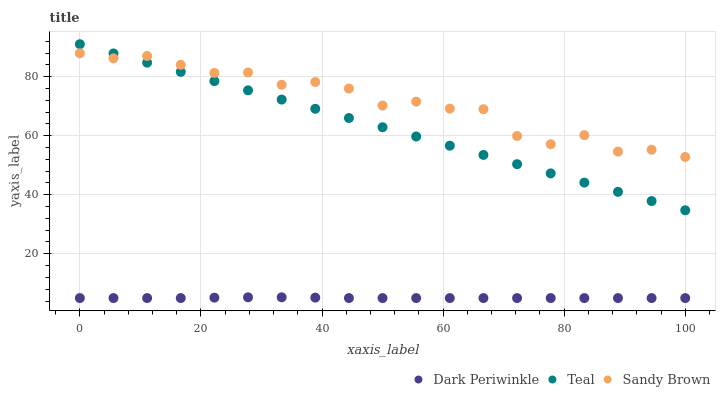Does Dark Periwinkle have the minimum area under the curve?
Answer yes or no. Yes. Does Sandy Brown have the maximum area under the curve?
Answer yes or no. Yes. Does Teal have the minimum area under the curve?
Answer yes or no. No. Does Teal have the maximum area under the curve?
Answer yes or no. No. Is Teal the smoothest?
Answer yes or no. Yes. Is Sandy Brown the roughest?
Answer yes or no. Yes. Is Dark Periwinkle the smoothest?
Answer yes or no. No. Is Dark Periwinkle the roughest?
Answer yes or no. No. Does Dark Periwinkle have the lowest value?
Answer yes or no. Yes. Does Teal have the lowest value?
Answer yes or no. No. Does Teal have the highest value?
Answer yes or no. Yes. Does Dark Periwinkle have the highest value?
Answer yes or no. No. Is Dark Periwinkle less than Teal?
Answer yes or no. Yes. Is Sandy Brown greater than Dark Periwinkle?
Answer yes or no. Yes. Does Teal intersect Sandy Brown?
Answer yes or no. Yes. Is Teal less than Sandy Brown?
Answer yes or no. No. Is Teal greater than Sandy Brown?
Answer yes or no. No. Does Dark Periwinkle intersect Teal?
Answer yes or no. No. 